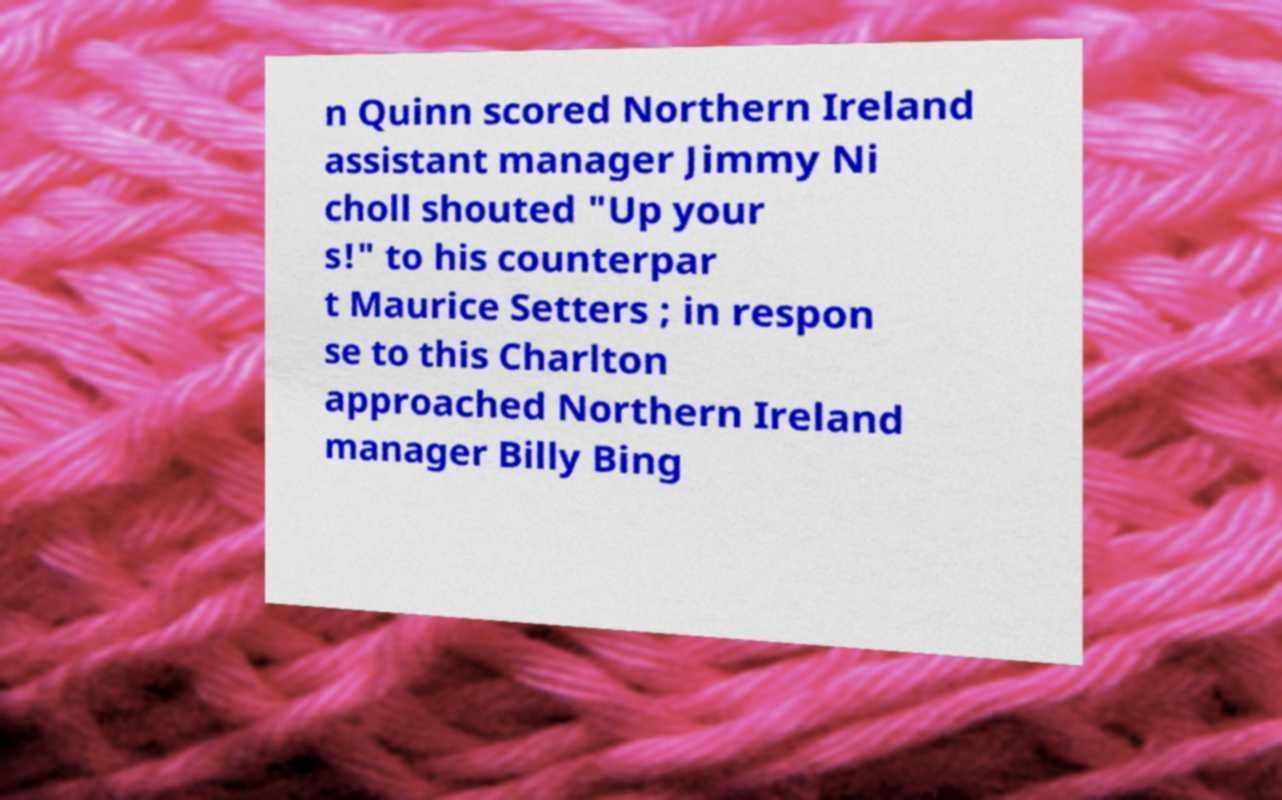Could you extract and type out the text from this image? n Quinn scored Northern Ireland assistant manager Jimmy Ni choll shouted "Up your s!" to his counterpar t Maurice Setters ; in respon se to this Charlton approached Northern Ireland manager Billy Bing 